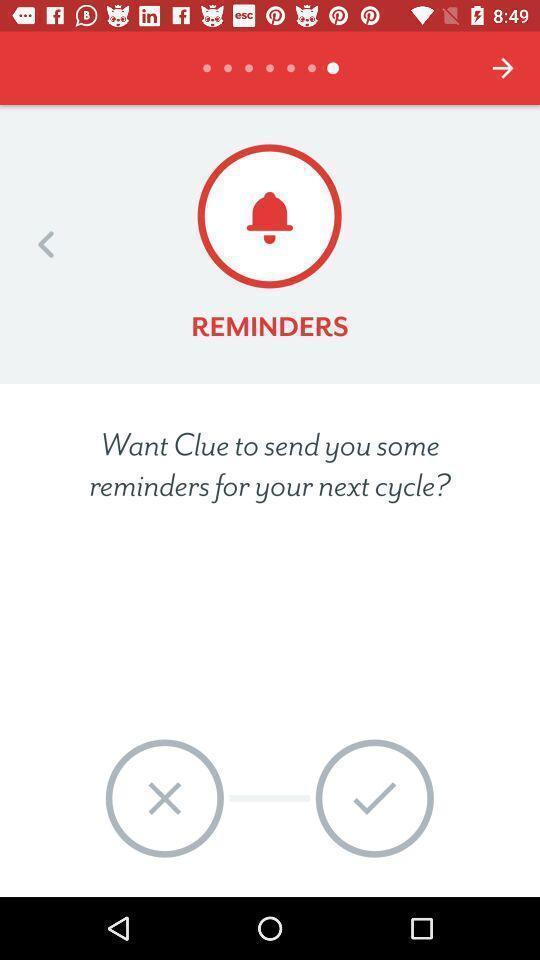Provide a description of this screenshot. Reminders page of a period tracker application. 